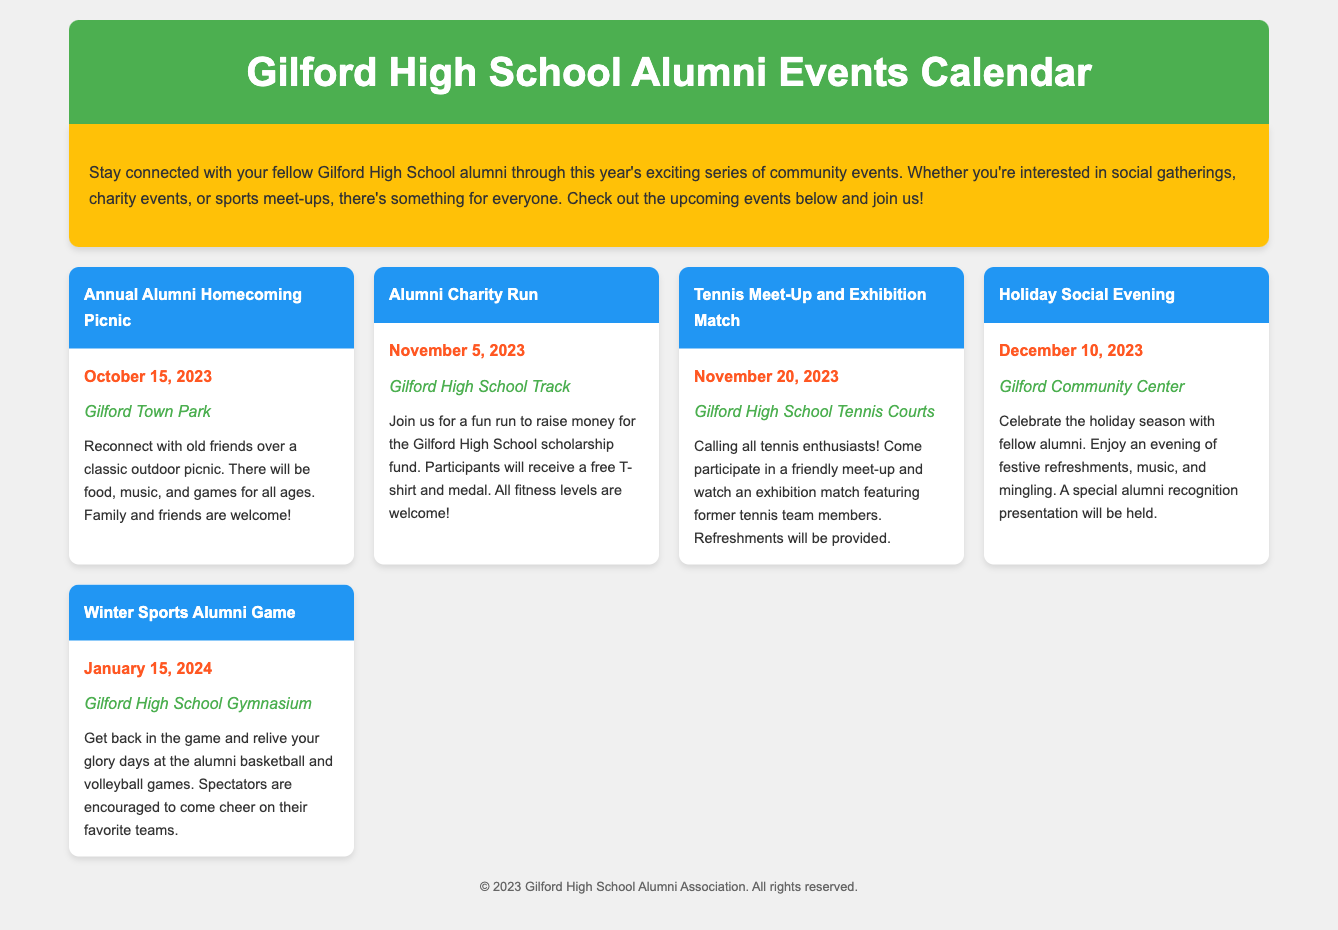What is the title of the document? The title of the document is specified within the <title> tag in the header section.
Answer: Gilford High School Alumni Events Calendar What is the date of the Annual Alumni Homecoming Picnic? The date is mentioned within the event details for the Annual Alumni Homecoming Picnic.
Answer: October 15, 2023 Where will the Alumni Charity Run take place? The location is stated in the event details for the Alumni Charity Run.
Answer: Gilford High School Track What event is scheduled for November 20, 2023? This specific event is mentioned along with its date in the events list.
Answer: Tennis Meet-Up and Exhibition Match How many events are listed in the calendar? The total number of events can be counted from the event cards displayed in the document.
Answer: 5 What type of event is occurring on January 15, 2024? The type of event is described in the details for the event occurring on that date.
Answer: Winter Sports Alumni Game What color is the header background? The header background color is specified in the CSS styling of the document.
Answer: #4CAF50 What kind of atmosphere does the Alumni Charity Run promote? The description of the Alumni Charity Run indicates the atmosphere it promotes.
Answer: Fun What kind of refreshments will be provided during the Tennis Meet-Up? The refreshments are mentioned specifically in the event details for the Tennis Meet-Up.
Answer: Provided 